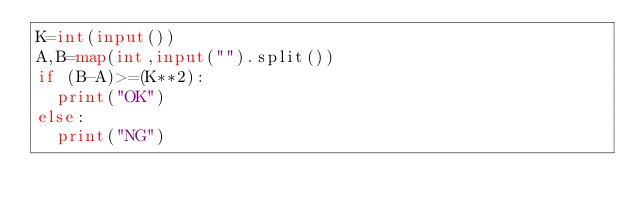<code> <loc_0><loc_0><loc_500><loc_500><_Python_>K=int(input())
A,B=map(int,input("").split())
if (B-A)>=(K**2):
  print("OK")
else:
  print("NG")</code> 